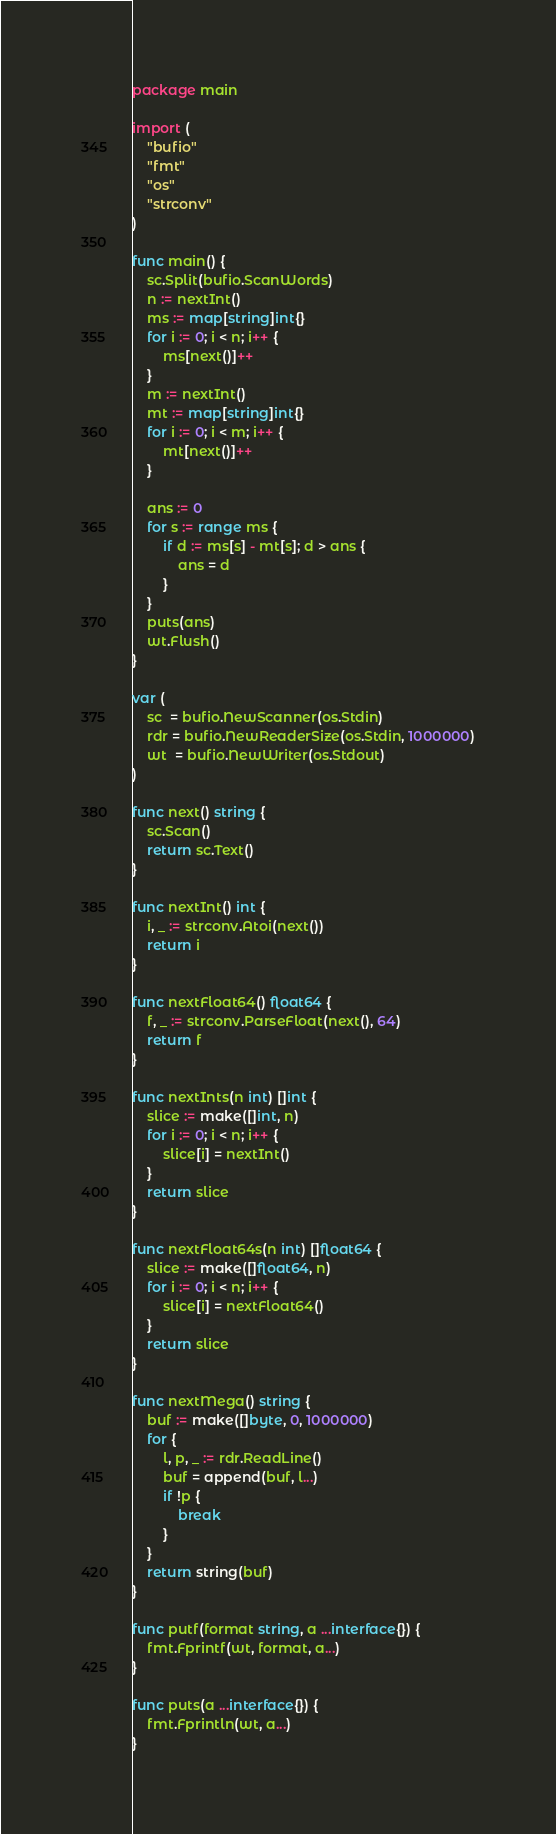Convert code to text. <code><loc_0><loc_0><loc_500><loc_500><_Go_>package main

import (
	"bufio"
	"fmt"
	"os"
	"strconv"
)

func main() {
	sc.Split(bufio.ScanWords)
	n := nextInt()
	ms := map[string]int{}
	for i := 0; i < n; i++ {
		ms[next()]++
	}
	m := nextInt()
	mt := map[string]int{}
	for i := 0; i < m; i++ {
		mt[next()]++
	}

	ans := 0
	for s := range ms {
		if d := ms[s] - mt[s]; d > ans {
			ans = d
		}
	}
	puts(ans)
	wt.Flush()
}

var (
	sc  = bufio.NewScanner(os.Stdin)
	rdr = bufio.NewReaderSize(os.Stdin, 1000000)
	wt  = bufio.NewWriter(os.Stdout)
)

func next() string {
	sc.Scan()
	return sc.Text()
}

func nextInt() int {
	i, _ := strconv.Atoi(next())
	return i
}

func nextFloat64() float64 {
	f, _ := strconv.ParseFloat(next(), 64)
	return f
}

func nextInts(n int) []int {
	slice := make([]int, n)
	for i := 0; i < n; i++ {
		slice[i] = nextInt()
	}
	return slice
}

func nextFloat64s(n int) []float64 {
	slice := make([]float64, n)
	for i := 0; i < n; i++ {
		slice[i] = nextFloat64()
	}
	return slice
}

func nextMega() string {
	buf := make([]byte, 0, 1000000)
	for {
		l, p, _ := rdr.ReadLine()
		buf = append(buf, l...)
		if !p {
			break
		}
	}
	return string(buf)
}

func putf(format string, a ...interface{}) {
	fmt.Fprintf(wt, format, a...)
}

func puts(a ...interface{}) {
	fmt.Fprintln(wt, a...)
}
</code> 